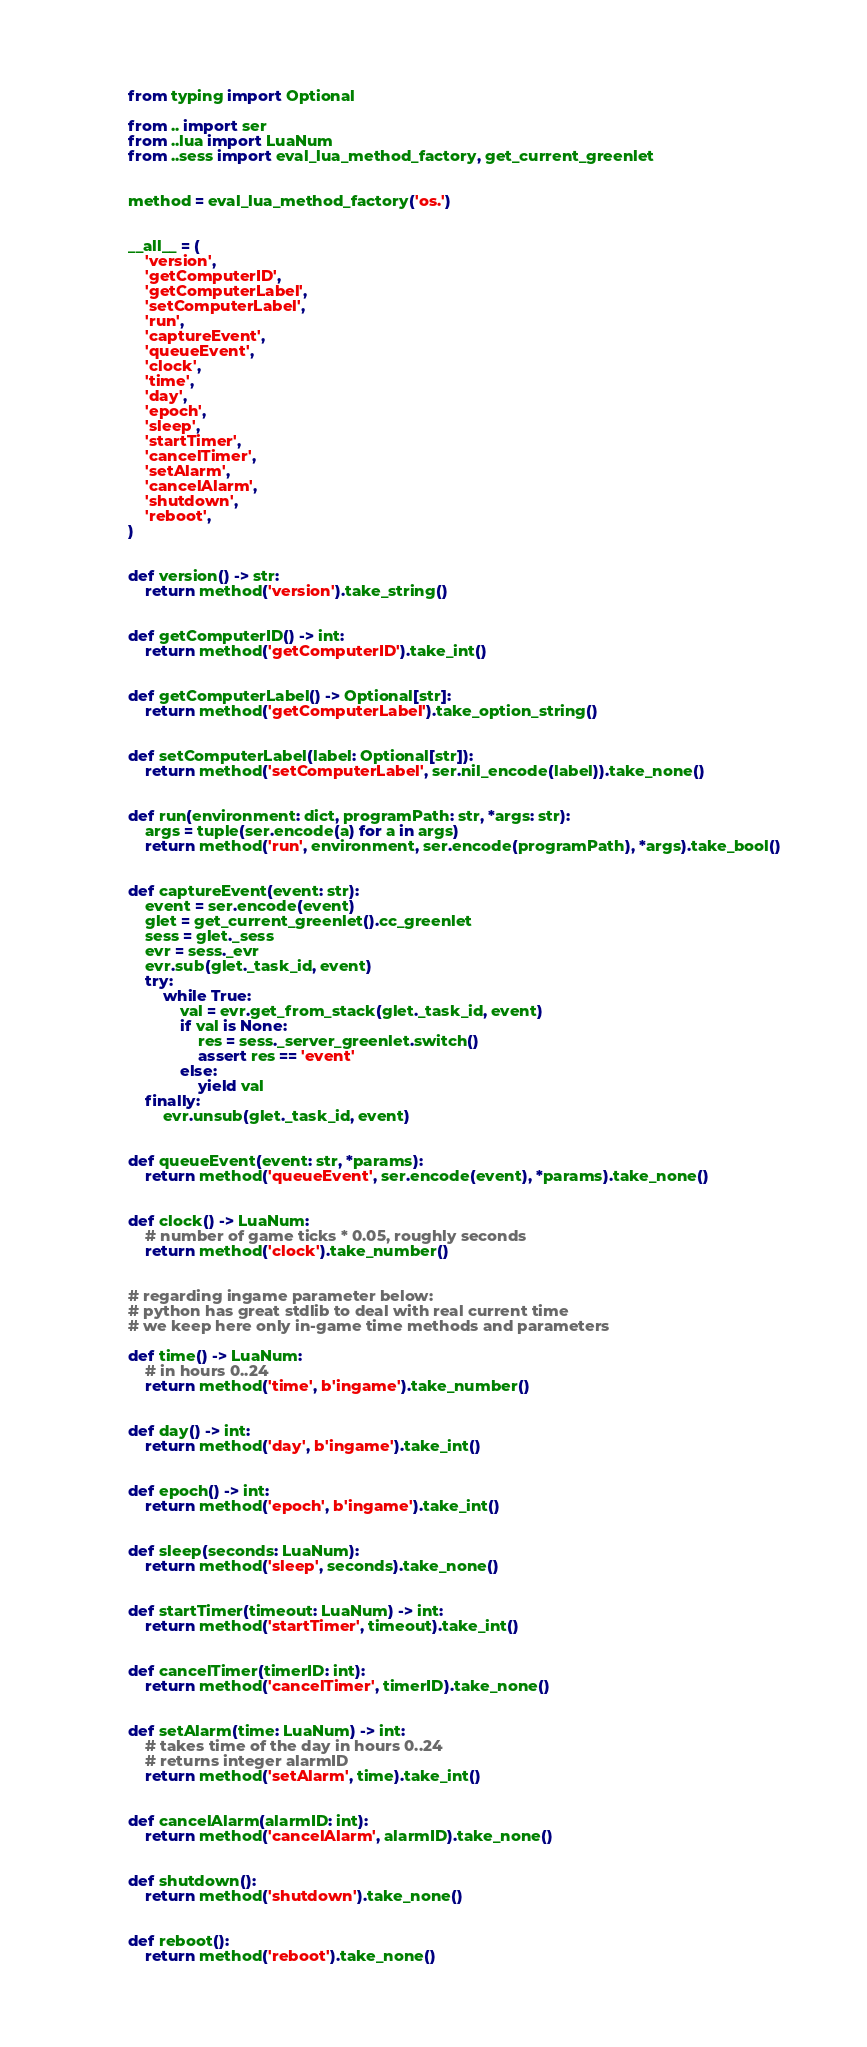Convert code to text. <code><loc_0><loc_0><loc_500><loc_500><_Python_>from typing import Optional

from .. import ser
from ..lua import LuaNum
from ..sess import eval_lua_method_factory, get_current_greenlet


method = eval_lua_method_factory('os.')


__all__ = (
    'version',
    'getComputerID',
    'getComputerLabel',
    'setComputerLabel',
    'run',
    'captureEvent',
    'queueEvent',
    'clock',
    'time',
    'day',
    'epoch',
    'sleep',
    'startTimer',
    'cancelTimer',
    'setAlarm',
    'cancelAlarm',
    'shutdown',
    'reboot',
)


def version() -> str:
    return method('version').take_string()


def getComputerID() -> int:
    return method('getComputerID').take_int()


def getComputerLabel() -> Optional[str]:
    return method('getComputerLabel').take_option_string()


def setComputerLabel(label: Optional[str]):
    return method('setComputerLabel', ser.nil_encode(label)).take_none()


def run(environment: dict, programPath: str, *args: str):
    args = tuple(ser.encode(a) for a in args)
    return method('run', environment, ser.encode(programPath), *args).take_bool()


def captureEvent(event: str):
    event = ser.encode(event)
    glet = get_current_greenlet().cc_greenlet
    sess = glet._sess
    evr = sess._evr
    evr.sub(glet._task_id, event)
    try:
        while True:
            val = evr.get_from_stack(glet._task_id, event)
            if val is None:
                res = sess._server_greenlet.switch()
                assert res == 'event'
            else:
                yield val
    finally:
        evr.unsub(glet._task_id, event)


def queueEvent(event: str, *params):
    return method('queueEvent', ser.encode(event), *params).take_none()


def clock() -> LuaNum:
    # number of game ticks * 0.05, roughly seconds
    return method('clock').take_number()


# regarding ingame parameter below:
# python has great stdlib to deal with real current time
# we keep here only in-game time methods and parameters

def time() -> LuaNum:
    # in hours 0..24
    return method('time', b'ingame').take_number()


def day() -> int:
    return method('day', b'ingame').take_int()


def epoch() -> int:
    return method('epoch', b'ingame').take_int()


def sleep(seconds: LuaNum):
    return method('sleep', seconds).take_none()


def startTimer(timeout: LuaNum) -> int:
    return method('startTimer', timeout).take_int()


def cancelTimer(timerID: int):
    return method('cancelTimer', timerID).take_none()


def setAlarm(time: LuaNum) -> int:
    # takes time of the day in hours 0..24
    # returns integer alarmID
    return method('setAlarm', time).take_int()


def cancelAlarm(alarmID: int):
    return method('cancelAlarm', alarmID).take_none()


def shutdown():
    return method('shutdown').take_none()


def reboot():
    return method('reboot').take_none()
</code> 